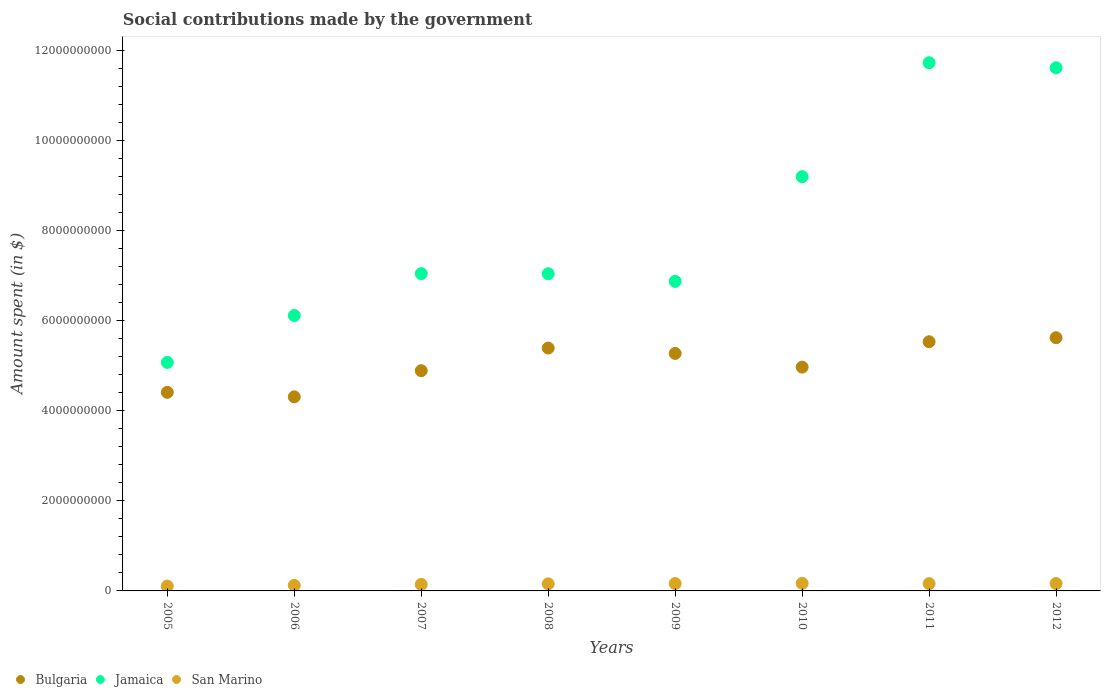Is the number of dotlines equal to the number of legend labels?
Provide a short and direct response. Yes. What is the amount spent on social contributions in Bulgaria in 2012?
Offer a very short reply. 5.62e+09. Across all years, what is the maximum amount spent on social contributions in San Marino?
Your answer should be compact. 1.68e+08. Across all years, what is the minimum amount spent on social contributions in Bulgaria?
Offer a very short reply. 4.31e+09. In which year was the amount spent on social contributions in San Marino maximum?
Keep it short and to the point. 2010. What is the total amount spent on social contributions in Jamaica in the graph?
Provide a short and direct response. 6.47e+1. What is the difference between the amount spent on social contributions in Bulgaria in 2008 and that in 2012?
Keep it short and to the point. -2.30e+08. What is the difference between the amount spent on social contributions in Bulgaria in 2006 and the amount spent on social contributions in San Marino in 2009?
Keep it short and to the point. 4.15e+09. What is the average amount spent on social contributions in Bulgaria per year?
Your response must be concise. 5.05e+09. In the year 2005, what is the difference between the amount spent on social contributions in San Marino and amount spent on social contributions in Jamaica?
Your answer should be very brief. -4.97e+09. In how many years, is the amount spent on social contributions in Bulgaria greater than 8400000000 $?
Give a very brief answer. 0. What is the ratio of the amount spent on social contributions in San Marino in 2008 to that in 2009?
Provide a short and direct response. 0.96. Is the amount spent on social contributions in Jamaica in 2006 less than that in 2009?
Make the answer very short. Yes. Is the difference between the amount spent on social contributions in San Marino in 2008 and 2009 greater than the difference between the amount spent on social contributions in Jamaica in 2008 and 2009?
Keep it short and to the point. No. What is the difference between the highest and the second highest amount spent on social contributions in San Marino?
Provide a short and direct response. 3.69e+06. What is the difference between the highest and the lowest amount spent on social contributions in San Marino?
Provide a succinct answer. 6.01e+07. Does the amount spent on social contributions in Bulgaria monotonically increase over the years?
Make the answer very short. No. Is the amount spent on social contributions in San Marino strictly greater than the amount spent on social contributions in Bulgaria over the years?
Ensure brevity in your answer.  No. How many years are there in the graph?
Offer a very short reply. 8. What is the difference between two consecutive major ticks on the Y-axis?
Provide a succinct answer. 2.00e+09. Does the graph contain any zero values?
Offer a very short reply. No. Where does the legend appear in the graph?
Your response must be concise. Bottom left. How many legend labels are there?
Your answer should be very brief. 3. How are the legend labels stacked?
Your response must be concise. Horizontal. What is the title of the graph?
Your answer should be very brief. Social contributions made by the government. Does "Chile" appear as one of the legend labels in the graph?
Give a very brief answer. No. What is the label or title of the Y-axis?
Your answer should be compact. Amount spent (in $). What is the Amount spent (in $) in Bulgaria in 2005?
Offer a terse response. 4.41e+09. What is the Amount spent (in $) in Jamaica in 2005?
Give a very brief answer. 5.07e+09. What is the Amount spent (in $) of San Marino in 2005?
Make the answer very short. 1.08e+08. What is the Amount spent (in $) in Bulgaria in 2006?
Offer a terse response. 4.31e+09. What is the Amount spent (in $) in Jamaica in 2006?
Provide a succinct answer. 6.12e+09. What is the Amount spent (in $) in San Marino in 2006?
Provide a short and direct response. 1.23e+08. What is the Amount spent (in $) of Bulgaria in 2007?
Give a very brief answer. 4.89e+09. What is the Amount spent (in $) of Jamaica in 2007?
Give a very brief answer. 7.05e+09. What is the Amount spent (in $) in San Marino in 2007?
Provide a succinct answer. 1.44e+08. What is the Amount spent (in $) in Bulgaria in 2008?
Provide a succinct answer. 5.39e+09. What is the Amount spent (in $) in Jamaica in 2008?
Keep it short and to the point. 7.04e+09. What is the Amount spent (in $) of San Marino in 2008?
Provide a succinct answer. 1.58e+08. What is the Amount spent (in $) in Bulgaria in 2009?
Your answer should be compact. 5.27e+09. What is the Amount spent (in $) in Jamaica in 2009?
Provide a succinct answer. 6.87e+09. What is the Amount spent (in $) of San Marino in 2009?
Your response must be concise. 1.64e+08. What is the Amount spent (in $) of Bulgaria in 2010?
Your response must be concise. 4.97e+09. What is the Amount spent (in $) in Jamaica in 2010?
Make the answer very short. 9.20e+09. What is the Amount spent (in $) of San Marino in 2010?
Your answer should be compact. 1.68e+08. What is the Amount spent (in $) of Bulgaria in 2011?
Your answer should be very brief. 5.53e+09. What is the Amount spent (in $) of Jamaica in 2011?
Your answer should be very brief. 1.17e+1. What is the Amount spent (in $) of San Marino in 2011?
Make the answer very short. 1.62e+08. What is the Amount spent (in $) in Bulgaria in 2012?
Offer a terse response. 5.62e+09. What is the Amount spent (in $) of Jamaica in 2012?
Offer a terse response. 1.16e+1. What is the Amount spent (in $) of San Marino in 2012?
Make the answer very short. 1.64e+08. Across all years, what is the maximum Amount spent (in $) in Bulgaria?
Your response must be concise. 5.62e+09. Across all years, what is the maximum Amount spent (in $) of Jamaica?
Offer a very short reply. 1.17e+1. Across all years, what is the maximum Amount spent (in $) of San Marino?
Make the answer very short. 1.68e+08. Across all years, what is the minimum Amount spent (in $) of Bulgaria?
Give a very brief answer. 4.31e+09. Across all years, what is the minimum Amount spent (in $) in Jamaica?
Your response must be concise. 5.07e+09. Across all years, what is the minimum Amount spent (in $) of San Marino?
Offer a very short reply. 1.08e+08. What is the total Amount spent (in $) in Bulgaria in the graph?
Give a very brief answer. 4.04e+1. What is the total Amount spent (in $) of Jamaica in the graph?
Give a very brief answer. 6.47e+1. What is the total Amount spent (in $) of San Marino in the graph?
Give a very brief answer. 1.19e+09. What is the difference between the Amount spent (in $) of Bulgaria in 2005 and that in 2006?
Offer a very short reply. 1.01e+08. What is the difference between the Amount spent (in $) in Jamaica in 2005 and that in 2006?
Offer a very short reply. -1.04e+09. What is the difference between the Amount spent (in $) of San Marino in 2005 and that in 2006?
Your response must be concise. -1.56e+07. What is the difference between the Amount spent (in $) in Bulgaria in 2005 and that in 2007?
Provide a short and direct response. -4.81e+08. What is the difference between the Amount spent (in $) of Jamaica in 2005 and that in 2007?
Your response must be concise. -1.97e+09. What is the difference between the Amount spent (in $) of San Marino in 2005 and that in 2007?
Offer a terse response. -3.61e+07. What is the difference between the Amount spent (in $) of Bulgaria in 2005 and that in 2008?
Your answer should be compact. -9.83e+08. What is the difference between the Amount spent (in $) of Jamaica in 2005 and that in 2008?
Offer a very short reply. -1.97e+09. What is the difference between the Amount spent (in $) in San Marino in 2005 and that in 2008?
Provide a succinct answer. -4.99e+07. What is the difference between the Amount spent (in $) in Bulgaria in 2005 and that in 2009?
Keep it short and to the point. -8.63e+08. What is the difference between the Amount spent (in $) of Jamaica in 2005 and that in 2009?
Your answer should be compact. -1.80e+09. What is the difference between the Amount spent (in $) in San Marino in 2005 and that in 2009?
Your response must be concise. -5.61e+07. What is the difference between the Amount spent (in $) of Bulgaria in 2005 and that in 2010?
Keep it short and to the point. -5.60e+08. What is the difference between the Amount spent (in $) of Jamaica in 2005 and that in 2010?
Provide a short and direct response. -4.13e+09. What is the difference between the Amount spent (in $) in San Marino in 2005 and that in 2010?
Keep it short and to the point. -6.01e+07. What is the difference between the Amount spent (in $) of Bulgaria in 2005 and that in 2011?
Offer a very short reply. -1.12e+09. What is the difference between the Amount spent (in $) of Jamaica in 2005 and that in 2011?
Your answer should be very brief. -6.65e+09. What is the difference between the Amount spent (in $) in San Marino in 2005 and that in 2011?
Keep it short and to the point. -5.40e+07. What is the difference between the Amount spent (in $) in Bulgaria in 2005 and that in 2012?
Offer a very short reply. -1.21e+09. What is the difference between the Amount spent (in $) of Jamaica in 2005 and that in 2012?
Provide a short and direct response. -6.54e+09. What is the difference between the Amount spent (in $) in San Marino in 2005 and that in 2012?
Your answer should be very brief. -5.64e+07. What is the difference between the Amount spent (in $) of Bulgaria in 2006 and that in 2007?
Provide a succinct answer. -5.81e+08. What is the difference between the Amount spent (in $) of Jamaica in 2006 and that in 2007?
Ensure brevity in your answer.  -9.30e+08. What is the difference between the Amount spent (in $) of San Marino in 2006 and that in 2007?
Ensure brevity in your answer.  -2.05e+07. What is the difference between the Amount spent (in $) of Bulgaria in 2006 and that in 2008?
Offer a very short reply. -1.08e+09. What is the difference between the Amount spent (in $) of Jamaica in 2006 and that in 2008?
Provide a short and direct response. -9.27e+08. What is the difference between the Amount spent (in $) of San Marino in 2006 and that in 2008?
Provide a short and direct response. -3.43e+07. What is the difference between the Amount spent (in $) in Bulgaria in 2006 and that in 2009?
Make the answer very short. -9.64e+08. What is the difference between the Amount spent (in $) in Jamaica in 2006 and that in 2009?
Your answer should be very brief. -7.58e+08. What is the difference between the Amount spent (in $) in San Marino in 2006 and that in 2009?
Give a very brief answer. -4.05e+07. What is the difference between the Amount spent (in $) in Bulgaria in 2006 and that in 2010?
Your response must be concise. -6.61e+08. What is the difference between the Amount spent (in $) of Jamaica in 2006 and that in 2010?
Offer a very short reply. -3.08e+09. What is the difference between the Amount spent (in $) of San Marino in 2006 and that in 2010?
Your answer should be very brief. -4.44e+07. What is the difference between the Amount spent (in $) of Bulgaria in 2006 and that in 2011?
Your response must be concise. -1.22e+09. What is the difference between the Amount spent (in $) in Jamaica in 2006 and that in 2011?
Give a very brief answer. -5.61e+09. What is the difference between the Amount spent (in $) of San Marino in 2006 and that in 2011?
Provide a succinct answer. -3.84e+07. What is the difference between the Amount spent (in $) of Bulgaria in 2006 and that in 2012?
Make the answer very short. -1.31e+09. What is the difference between the Amount spent (in $) in Jamaica in 2006 and that in 2012?
Give a very brief answer. -5.50e+09. What is the difference between the Amount spent (in $) of San Marino in 2006 and that in 2012?
Offer a very short reply. -4.08e+07. What is the difference between the Amount spent (in $) of Bulgaria in 2007 and that in 2008?
Offer a very short reply. -5.02e+08. What is the difference between the Amount spent (in $) of Jamaica in 2007 and that in 2008?
Keep it short and to the point. 2.79e+06. What is the difference between the Amount spent (in $) in San Marino in 2007 and that in 2008?
Your answer should be very brief. -1.39e+07. What is the difference between the Amount spent (in $) in Bulgaria in 2007 and that in 2009?
Offer a terse response. -3.83e+08. What is the difference between the Amount spent (in $) in Jamaica in 2007 and that in 2009?
Ensure brevity in your answer.  1.72e+08. What is the difference between the Amount spent (in $) in San Marino in 2007 and that in 2009?
Make the answer very short. -2.00e+07. What is the difference between the Amount spent (in $) in Bulgaria in 2007 and that in 2010?
Your answer should be very brief. -7.95e+07. What is the difference between the Amount spent (in $) in Jamaica in 2007 and that in 2010?
Your answer should be compact. -2.15e+09. What is the difference between the Amount spent (in $) in San Marino in 2007 and that in 2010?
Provide a short and direct response. -2.40e+07. What is the difference between the Amount spent (in $) of Bulgaria in 2007 and that in 2011?
Offer a very short reply. -6.42e+08. What is the difference between the Amount spent (in $) in Jamaica in 2007 and that in 2011?
Provide a succinct answer. -4.68e+09. What is the difference between the Amount spent (in $) in San Marino in 2007 and that in 2011?
Provide a short and direct response. -1.80e+07. What is the difference between the Amount spent (in $) in Bulgaria in 2007 and that in 2012?
Offer a very short reply. -7.32e+08. What is the difference between the Amount spent (in $) of Jamaica in 2007 and that in 2012?
Make the answer very short. -4.57e+09. What is the difference between the Amount spent (in $) of San Marino in 2007 and that in 2012?
Provide a short and direct response. -2.03e+07. What is the difference between the Amount spent (in $) of Bulgaria in 2008 and that in 2009?
Your response must be concise. 1.20e+08. What is the difference between the Amount spent (in $) of Jamaica in 2008 and that in 2009?
Provide a succinct answer. 1.69e+08. What is the difference between the Amount spent (in $) in San Marino in 2008 and that in 2009?
Your answer should be very brief. -6.16e+06. What is the difference between the Amount spent (in $) of Bulgaria in 2008 and that in 2010?
Make the answer very short. 4.23e+08. What is the difference between the Amount spent (in $) of Jamaica in 2008 and that in 2010?
Your response must be concise. -2.16e+09. What is the difference between the Amount spent (in $) of San Marino in 2008 and that in 2010?
Ensure brevity in your answer.  -1.01e+07. What is the difference between the Amount spent (in $) of Bulgaria in 2008 and that in 2011?
Ensure brevity in your answer.  -1.40e+08. What is the difference between the Amount spent (in $) in Jamaica in 2008 and that in 2011?
Your answer should be compact. -4.68e+09. What is the difference between the Amount spent (in $) in San Marino in 2008 and that in 2011?
Your answer should be very brief. -4.11e+06. What is the difference between the Amount spent (in $) in Bulgaria in 2008 and that in 2012?
Provide a short and direct response. -2.30e+08. What is the difference between the Amount spent (in $) of Jamaica in 2008 and that in 2012?
Ensure brevity in your answer.  -4.57e+09. What is the difference between the Amount spent (in $) in San Marino in 2008 and that in 2012?
Provide a succinct answer. -6.42e+06. What is the difference between the Amount spent (in $) of Bulgaria in 2009 and that in 2010?
Provide a short and direct response. 3.03e+08. What is the difference between the Amount spent (in $) of Jamaica in 2009 and that in 2010?
Ensure brevity in your answer.  -2.33e+09. What is the difference between the Amount spent (in $) in San Marino in 2009 and that in 2010?
Your answer should be very brief. -3.95e+06. What is the difference between the Amount spent (in $) in Bulgaria in 2009 and that in 2011?
Ensure brevity in your answer.  -2.60e+08. What is the difference between the Amount spent (in $) in Jamaica in 2009 and that in 2011?
Your answer should be compact. -4.85e+09. What is the difference between the Amount spent (in $) in San Marino in 2009 and that in 2011?
Provide a succinct answer. 2.05e+06. What is the difference between the Amount spent (in $) of Bulgaria in 2009 and that in 2012?
Provide a short and direct response. -3.49e+08. What is the difference between the Amount spent (in $) of Jamaica in 2009 and that in 2012?
Make the answer very short. -4.74e+09. What is the difference between the Amount spent (in $) in San Marino in 2009 and that in 2012?
Provide a short and direct response. -2.64e+05. What is the difference between the Amount spent (in $) in Bulgaria in 2010 and that in 2011?
Make the answer very short. -5.63e+08. What is the difference between the Amount spent (in $) in Jamaica in 2010 and that in 2011?
Make the answer very short. -2.53e+09. What is the difference between the Amount spent (in $) of San Marino in 2010 and that in 2011?
Offer a terse response. 6.01e+06. What is the difference between the Amount spent (in $) in Bulgaria in 2010 and that in 2012?
Your response must be concise. -6.53e+08. What is the difference between the Amount spent (in $) of Jamaica in 2010 and that in 2012?
Keep it short and to the point. -2.42e+09. What is the difference between the Amount spent (in $) in San Marino in 2010 and that in 2012?
Keep it short and to the point. 3.69e+06. What is the difference between the Amount spent (in $) in Bulgaria in 2011 and that in 2012?
Give a very brief answer. -8.99e+07. What is the difference between the Amount spent (in $) of Jamaica in 2011 and that in 2012?
Make the answer very short. 1.11e+08. What is the difference between the Amount spent (in $) of San Marino in 2011 and that in 2012?
Your answer should be compact. -2.32e+06. What is the difference between the Amount spent (in $) of Bulgaria in 2005 and the Amount spent (in $) of Jamaica in 2006?
Give a very brief answer. -1.71e+09. What is the difference between the Amount spent (in $) of Bulgaria in 2005 and the Amount spent (in $) of San Marino in 2006?
Provide a short and direct response. 4.29e+09. What is the difference between the Amount spent (in $) in Jamaica in 2005 and the Amount spent (in $) in San Marino in 2006?
Your response must be concise. 4.95e+09. What is the difference between the Amount spent (in $) of Bulgaria in 2005 and the Amount spent (in $) of Jamaica in 2007?
Provide a short and direct response. -2.64e+09. What is the difference between the Amount spent (in $) of Bulgaria in 2005 and the Amount spent (in $) of San Marino in 2007?
Provide a short and direct response. 4.27e+09. What is the difference between the Amount spent (in $) of Jamaica in 2005 and the Amount spent (in $) of San Marino in 2007?
Ensure brevity in your answer.  4.93e+09. What is the difference between the Amount spent (in $) in Bulgaria in 2005 and the Amount spent (in $) in Jamaica in 2008?
Your answer should be compact. -2.63e+09. What is the difference between the Amount spent (in $) in Bulgaria in 2005 and the Amount spent (in $) in San Marino in 2008?
Give a very brief answer. 4.25e+09. What is the difference between the Amount spent (in $) of Jamaica in 2005 and the Amount spent (in $) of San Marino in 2008?
Provide a succinct answer. 4.92e+09. What is the difference between the Amount spent (in $) of Bulgaria in 2005 and the Amount spent (in $) of Jamaica in 2009?
Offer a very short reply. -2.46e+09. What is the difference between the Amount spent (in $) of Bulgaria in 2005 and the Amount spent (in $) of San Marino in 2009?
Make the answer very short. 4.25e+09. What is the difference between the Amount spent (in $) of Jamaica in 2005 and the Amount spent (in $) of San Marino in 2009?
Your answer should be very brief. 4.91e+09. What is the difference between the Amount spent (in $) of Bulgaria in 2005 and the Amount spent (in $) of Jamaica in 2010?
Provide a short and direct response. -4.79e+09. What is the difference between the Amount spent (in $) of Bulgaria in 2005 and the Amount spent (in $) of San Marino in 2010?
Your answer should be very brief. 4.24e+09. What is the difference between the Amount spent (in $) of Jamaica in 2005 and the Amount spent (in $) of San Marino in 2010?
Provide a short and direct response. 4.91e+09. What is the difference between the Amount spent (in $) of Bulgaria in 2005 and the Amount spent (in $) of Jamaica in 2011?
Your answer should be compact. -7.32e+09. What is the difference between the Amount spent (in $) of Bulgaria in 2005 and the Amount spent (in $) of San Marino in 2011?
Keep it short and to the point. 4.25e+09. What is the difference between the Amount spent (in $) of Jamaica in 2005 and the Amount spent (in $) of San Marino in 2011?
Your response must be concise. 4.91e+09. What is the difference between the Amount spent (in $) of Bulgaria in 2005 and the Amount spent (in $) of Jamaica in 2012?
Your answer should be compact. -7.21e+09. What is the difference between the Amount spent (in $) of Bulgaria in 2005 and the Amount spent (in $) of San Marino in 2012?
Your answer should be very brief. 4.25e+09. What is the difference between the Amount spent (in $) of Jamaica in 2005 and the Amount spent (in $) of San Marino in 2012?
Provide a succinct answer. 4.91e+09. What is the difference between the Amount spent (in $) of Bulgaria in 2006 and the Amount spent (in $) of Jamaica in 2007?
Give a very brief answer. -2.74e+09. What is the difference between the Amount spent (in $) in Bulgaria in 2006 and the Amount spent (in $) in San Marino in 2007?
Keep it short and to the point. 4.17e+09. What is the difference between the Amount spent (in $) in Jamaica in 2006 and the Amount spent (in $) in San Marino in 2007?
Provide a succinct answer. 5.97e+09. What is the difference between the Amount spent (in $) in Bulgaria in 2006 and the Amount spent (in $) in Jamaica in 2008?
Your answer should be very brief. -2.73e+09. What is the difference between the Amount spent (in $) of Bulgaria in 2006 and the Amount spent (in $) of San Marino in 2008?
Keep it short and to the point. 4.15e+09. What is the difference between the Amount spent (in $) of Jamaica in 2006 and the Amount spent (in $) of San Marino in 2008?
Your answer should be compact. 5.96e+09. What is the difference between the Amount spent (in $) of Bulgaria in 2006 and the Amount spent (in $) of Jamaica in 2009?
Provide a short and direct response. -2.56e+09. What is the difference between the Amount spent (in $) of Bulgaria in 2006 and the Amount spent (in $) of San Marino in 2009?
Keep it short and to the point. 4.15e+09. What is the difference between the Amount spent (in $) in Jamaica in 2006 and the Amount spent (in $) in San Marino in 2009?
Your response must be concise. 5.95e+09. What is the difference between the Amount spent (in $) in Bulgaria in 2006 and the Amount spent (in $) in Jamaica in 2010?
Make the answer very short. -4.89e+09. What is the difference between the Amount spent (in $) in Bulgaria in 2006 and the Amount spent (in $) in San Marino in 2010?
Provide a succinct answer. 4.14e+09. What is the difference between the Amount spent (in $) of Jamaica in 2006 and the Amount spent (in $) of San Marino in 2010?
Offer a terse response. 5.95e+09. What is the difference between the Amount spent (in $) of Bulgaria in 2006 and the Amount spent (in $) of Jamaica in 2011?
Ensure brevity in your answer.  -7.42e+09. What is the difference between the Amount spent (in $) of Bulgaria in 2006 and the Amount spent (in $) of San Marino in 2011?
Give a very brief answer. 4.15e+09. What is the difference between the Amount spent (in $) in Jamaica in 2006 and the Amount spent (in $) in San Marino in 2011?
Offer a terse response. 5.95e+09. What is the difference between the Amount spent (in $) in Bulgaria in 2006 and the Amount spent (in $) in Jamaica in 2012?
Provide a succinct answer. -7.31e+09. What is the difference between the Amount spent (in $) of Bulgaria in 2006 and the Amount spent (in $) of San Marino in 2012?
Your answer should be very brief. 4.15e+09. What is the difference between the Amount spent (in $) in Jamaica in 2006 and the Amount spent (in $) in San Marino in 2012?
Offer a very short reply. 5.95e+09. What is the difference between the Amount spent (in $) of Bulgaria in 2007 and the Amount spent (in $) of Jamaica in 2008?
Keep it short and to the point. -2.15e+09. What is the difference between the Amount spent (in $) of Bulgaria in 2007 and the Amount spent (in $) of San Marino in 2008?
Provide a short and direct response. 4.73e+09. What is the difference between the Amount spent (in $) of Jamaica in 2007 and the Amount spent (in $) of San Marino in 2008?
Provide a succinct answer. 6.89e+09. What is the difference between the Amount spent (in $) in Bulgaria in 2007 and the Amount spent (in $) in Jamaica in 2009?
Your response must be concise. -1.98e+09. What is the difference between the Amount spent (in $) in Bulgaria in 2007 and the Amount spent (in $) in San Marino in 2009?
Your response must be concise. 4.73e+09. What is the difference between the Amount spent (in $) of Jamaica in 2007 and the Amount spent (in $) of San Marino in 2009?
Offer a very short reply. 6.88e+09. What is the difference between the Amount spent (in $) in Bulgaria in 2007 and the Amount spent (in $) in Jamaica in 2010?
Your answer should be very brief. -4.31e+09. What is the difference between the Amount spent (in $) of Bulgaria in 2007 and the Amount spent (in $) of San Marino in 2010?
Your response must be concise. 4.72e+09. What is the difference between the Amount spent (in $) in Jamaica in 2007 and the Amount spent (in $) in San Marino in 2010?
Give a very brief answer. 6.88e+09. What is the difference between the Amount spent (in $) of Bulgaria in 2007 and the Amount spent (in $) of Jamaica in 2011?
Provide a short and direct response. -6.84e+09. What is the difference between the Amount spent (in $) in Bulgaria in 2007 and the Amount spent (in $) in San Marino in 2011?
Your response must be concise. 4.73e+09. What is the difference between the Amount spent (in $) of Jamaica in 2007 and the Amount spent (in $) of San Marino in 2011?
Offer a terse response. 6.88e+09. What is the difference between the Amount spent (in $) of Bulgaria in 2007 and the Amount spent (in $) of Jamaica in 2012?
Keep it short and to the point. -6.73e+09. What is the difference between the Amount spent (in $) of Bulgaria in 2007 and the Amount spent (in $) of San Marino in 2012?
Keep it short and to the point. 4.73e+09. What is the difference between the Amount spent (in $) in Jamaica in 2007 and the Amount spent (in $) in San Marino in 2012?
Give a very brief answer. 6.88e+09. What is the difference between the Amount spent (in $) of Bulgaria in 2008 and the Amount spent (in $) of Jamaica in 2009?
Your answer should be compact. -1.48e+09. What is the difference between the Amount spent (in $) in Bulgaria in 2008 and the Amount spent (in $) in San Marino in 2009?
Provide a short and direct response. 5.23e+09. What is the difference between the Amount spent (in $) of Jamaica in 2008 and the Amount spent (in $) of San Marino in 2009?
Your response must be concise. 6.88e+09. What is the difference between the Amount spent (in $) of Bulgaria in 2008 and the Amount spent (in $) of Jamaica in 2010?
Offer a very short reply. -3.81e+09. What is the difference between the Amount spent (in $) of Bulgaria in 2008 and the Amount spent (in $) of San Marino in 2010?
Make the answer very short. 5.22e+09. What is the difference between the Amount spent (in $) of Jamaica in 2008 and the Amount spent (in $) of San Marino in 2010?
Keep it short and to the point. 6.88e+09. What is the difference between the Amount spent (in $) of Bulgaria in 2008 and the Amount spent (in $) of Jamaica in 2011?
Offer a very short reply. -6.34e+09. What is the difference between the Amount spent (in $) in Bulgaria in 2008 and the Amount spent (in $) in San Marino in 2011?
Keep it short and to the point. 5.23e+09. What is the difference between the Amount spent (in $) of Jamaica in 2008 and the Amount spent (in $) of San Marino in 2011?
Provide a short and direct response. 6.88e+09. What is the difference between the Amount spent (in $) in Bulgaria in 2008 and the Amount spent (in $) in Jamaica in 2012?
Provide a short and direct response. -6.22e+09. What is the difference between the Amount spent (in $) of Bulgaria in 2008 and the Amount spent (in $) of San Marino in 2012?
Provide a succinct answer. 5.23e+09. What is the difference between the Amount spent (in $) in Jamaica in 2008 and the Amount spent (in $) in San Marino in 2012?
Make the answer very short. 6.88e+09. What is the difference between the Amount spent (in $) in Bulgaria in 2009 and the Amount spent (in $) in Jamaica in 2010?
Offer a very short reply. -3.93e+09. What is the difference between the Amount spent (in $) in Bulgaria in 2009 and the Amount spent (in $) in San Marino in 2010?
Provide a short and direct response. 5.11e+09. What is the difference between the Amount spent (in $) of Jamaica in 2009 and the Amount spent (in $) of San Marino in 2010?
Your answer should be compact. 6.71e+09. What is the difference between the Amount spent (in $) in Bulgaria in 2009 and the Amount spent (in $) in Jamaica in 2011?
Your answer should be compact. -6.45e+09. What is the difference between the Amount spent (in $) of Bulgaria in 2009 and the Amount spent (in $) of San Marino in 2011?
Your answer should be compact. 5.11e+09. What is the difference between the Amount spent (in $) of Jamaica in 2009 and the Amount spent (in $) of San Marino in 2011?
Offer a very short reply. 6.71e+09. What is the difference between the Amount spent (in $) of Bulgaria in 2009 and the Amount spent (in $) of Jamaica in 2012?
Give a very brief answer. -6.34e+09. What is the difference between the Amount spent (in $) of Bulgaria in 2009 and the Amount spent (in $) of San Marino in 2012?
Your answer should be very brief. 5.11e+09. What is the difference between the Amount spent (in $) in Jamaica in 2009 and the Amount spent (in $) in San Marino in 2012?
Make the answer very short. 6.71e+09. What is the difference between the Amount spent (in $) of Bulgaria in 2010 and the Amount spent (in $) of Jamaica in 2011?
Give a very brief answer. -6.76e+09. What is the difference between the Amount spent (in $) in Bulgaria in 2010 and the Amount spent (in $) in San Marino in 2011?
Offer a terse response. 4.81e+09. What is the difference between the Amount spent (in $) in Jamaica in 2010 and the Amount spent (in $) in San Marino in 2011?
Your answer should be compact. 9.04e+09. What is the difference between the Amount spent (in $) of Bulgaria in 2010 and the Amount spent (in $) of Jamaica in 2012?
Ensure brevity in your answer.  -6.65e+09. What is the difference between the Amount spent (in $) in Bulgaria in 2010 and the Amount spent (in $) in San Marino in 2012?
Offer a terse response. 4.81e+09. What is the difference between the Amount spent (in $) of Jamaica in 2010 and the Amount spent (in $) of San Marino in 2012?
Keep it short and to the point. 9.04e+09. What is the difference between the Amount spent (in $) in Bulgaria in 2011 and the Amount spent (in $) in Jamaica in 2012?
Your answer should be very brief. -6.08e+09. What is the difference between the Amount spent (in $) of Bulgaria in 2011 and the Amount spent (in $) of San Marino in 2012?
Your response must be concise. 5.37e+09. What is the difference between the Amount spent (in $) in Jamaica in 2011 and the Amount spent (in $) in San Marino in 2012?
Offer a terse response. 1.16e+1. What is the average Amount spent (in $) in Bulgaria per year?
Keep it short and to the point. 5.05e+09. What is the average Amount spent (in $) in Jamaica per year?
Offer a terse response. 8.09e+09. What is the average Amount spent (in $) of San Marino per year?
Ensure brevity in your answer.  1.49e+08. In the year 2005, what is the difference between the Amount spent (in $) of Bulgaria and Amount spent (in $) of Jamaica?
Your answer should be very brief. -6.64e+08. In the year 2005, what is the difference between the Amount spent (in $) of Bulgaria and Amount spent (in $) of San Marino?
Ensure brevity in your answer.  4.30e+09. In the year 2005, what is the difference between the Amount spent (in $) of Jamaica and Amount spent (in $) of San Marino?
Your answer should be compact. 4.97e+09. In the year 2006, what is the difference between the Amount spent (in $) in Bulgaria and Amount spent (in $) in Jamaica?
Provide a short and direct response. -1.81e+09. In the year 2006, what is the difference between the Amount spent (in $) in Bulgaria and Amount spent (in $) in San Marino?
Make the answer very short. 4.19e+09. In the year 2006, what is the difference between the Amount spent (in $) in Jamaica and Amount spent (in $) in San Marino?
Provide a short and direct response. 5.99e+09. In the year 2007, what is the difference between the Amount spent (in $) of Bulgaria and Amount spent (in $) of Jamaica?
Provide a succinct answer. -2.16e+09. In the year 2007, what is the difference between the Amount spent (in $) in Bulgaria and Amount spent (in $) in San Marino?
Offer a terse response. 4.75e+09. In the year 2007, what is the difference between the Amount spent (in $) of Jamaica and Amount spent (in $) of San Marino?
Keep it short and to the point. 6.90e+09. In the year 2008, what is the difference between the Amount spent (in $) in Bulgaria and Amount spent (in $) in Jamaica?
Provide a succinct answer. -1.65e+09. In the year 2008, what is the difference between the Amount spent (in $) in Bulgaria and Amount spent (in $) in San Marino?
Provide a succinct answer. 5.24e+09. In the year 2008, what is the difference between the Amount spent (in $) of Jamaica and Amount spent (in $) of San Marino?
Provide a succinct answer. 6.89e+09. In the year 2009, what is the difference between the Amount spent (in $) of Bulgaria and Amount spent (in $) of Jamaica?
Make the answer very short. -1.60e+09. In the year 2009, what is the difference between the Amount spent (in $) of Bulgaria and Amount spent (in $) of San Marino?
Your answer should be very brief. 5.11e+09. In the year 2009, what is the difference between the Amount spent (in $) of Jamaica and Amount spent (in $) of San Marino?
Your answer should be compact. 6.71e+09. In the year 2010, what is the difference between the Amount spent (in $) of Bulgaria and Amount spent (in $) of Jamaica?
Ensure brevity in your answer.  -4.23e+09. In the year 2010, what is the difference between the Amount spent (in $) of Bulgaria and Amount spent (in $) of San Marino?
Provide a succinct answer. 4.80e+09. In the year 2010, what is the difference between the Amount spent (in $) of Jamaica and Amount spent (in $) of San Marino?
Your answer should be very brief. 9.03e+09. In the year 2011, what is the difference between the Amount spent (in $) in Bulgaria and Amount spent (in $) in Jamaica?
Provide a succinct answer. -6.20e+09. In the year 2011, what is the difference between the Amount spent (in $) in Bulgaria and Amount spent (in $) in San Marino?
Give a very brief answer. 5.37e+09. In the year 2011, what is the difference between the Amount spent (in $) in Jamaica and Amount spent (in $) in San Marino?
Give a very brief answer. 1.16e+1. In the year 2012, what is the difference between the Amount spent (in $) of Bulgaria and Amount spent (in $) of Jamaica?
Make the answer very short. -5.99e+09. In the year 2012, what is the difference between the Amount spent (in $) in Bulgaria and Amount spent (in $) in San Marino?
Offer a very short reply. 5.46e+09. In the year 2012, what is the difference between the Amount spent (in $) in Jamaica and Amount spent (in $) in San Marino?
Ensure brevity in your answer.  1.15e+1. What is the ratio of the Amount spent (in $) of Bulgaria in 2005 to that in 2006?
Make the answer very short. 1.02. What is the ratio of the Amount spent (in $) of Jamaica in 2005 to that in 2006?
Your answer should be compact. 0.83. What is the ratio of the Amount spent (in $) in San Marino in 2005 to that in 2006?
Provide a succinct answer. 0.87. What is the ratio of the Amount spent (in $) of Bulgaria in 2005 to that in 2007?
Your answer should be very brief. 0.9. What is the ratio of the Amount spent (in $) of Jamaica in 2005 to that in 2007?
Your answer should be very brief. 0.72. What is the ratio of the Amount spent (in $) of San Marino in 2005 to that in 2007?
Your response must be concise. 0.75. What is the ratio of the Amount spent (in $) in Bulgaria in 2005 to that in 2008?
Make the answer very short. 0.82. What is the ratio of the Amount spent (in $) of Jamaica in 2005 to that in 2008?
Your response must be concise. 0.72. What is the ratio of the Amount spent (in $) of San Marino in 2005 to that in 2008?
Provide a succinct answer. 0.68. What is the ratio of the Amount spent (in $) in Bulgaria in 2005 to that in 2009?
Your response must be concise. 0.84. What is the ratio of the Amount spent (in $) in Jamaica in 2005 to that in 2009?
Your response must be concise. 0.74. What is the ratio of the Amount spent (in $) of San Marino in 2005 to that in 2009?
Your answer should be very brief. 0.66. What is the ratio of the Amount spent (in $) in Bulgaria in 2005 to that in 2010?
Your answer should be very brief. 0.89. What is the ratio of the Amount spent (in $) of Jamaica in 2005 to that in 2010?
Offer a terse response. 0.55. What is the ratio of the Amount spent (in $) of San Marino in 2005 to that in 2010?
Provide a succinct answer. 0.64. What is the ratio of the Amount spent (in $) of Bulgaria in 2005 to that in 2011?
Your answer should be very brief. 0.8. What is the ratio of the Amount spent (in $) of Jamaica in 2005 to that in 2011?
Your answer should be compact. 0.43. What is the ratio of the Amount spent (in $) in San Marino in 2005 to that in 2011?
Give a very brief answer. 0.67. What is the ratio of the Amount spent (in $) in Bulgaria in 2005 to that in 2012?
Your response must be concise. 0.78. What is the ratio of the Amount spent (in $) of Jamaica in 2005 to that in 2012?
Give a very brief answer. 0.44. What is the ratio of the Amount spent (in $) of San Marino in 2005 to that in 2012?
Provide a succinct answer. 0.66. What is the ratio of the Amount spent (in $) of Bulgaria in 2006 to that in 2007?
Keep it short and to the point. 0.88. What is the ratio of the Amount spent (in $) of Jamaica in 2006 to that in 2007?
Make the answer very short. 0.87. What is the ratio of the Amount spent (in $) in San Marino in 2006 to that in 2007?
Your answer should be compact. 0.86. What is the ratio of the Amount spent (in $) of Bulgaria in 2006 to that in 2008?
Your answer should be compact. 0.8. What is the ratio of the Amount spent (in $) of Jamaica in 2006 to that in 2008?
Give a very brief answer. 0.87. What is the ratio of the Amount spent (in $) of San Marino in 2006 to that in 2008?
Offer a terse response. 0.78. What is the ratio of the Amount spent (in $) of Bulgaria in 2006 to that in 2009?
Ensure brevity in your answer.  0.82. What is the ratio of the Amount spent (in $) in Jamaica in 2006 to that in 2009?
Provide a succinct answer. 0.89. What is the ratio of the Amount spent (in $) of San Marino in 2006 to that in 2009?
Your answer should be compact. 0.75. What is the ratio of the Amount spent (in $) in Bulgaria in 2006 to that in 2010?
Your response must be concise. 0.87. What is the ratio of the Amount spent (in $) of Jamaica in 2006 to that in 2010?
Keep it short and to the point. 0.66. What is the ratio of the Amount spent (in $) in San Marino in 2006 to that in 2010?
Provide a succinct answer. 0.73. What is the ratio of the Amount spent (in $) of Bulgaria in 2006 to that in 2011?
Your answer should be very brief. 0.78. What is the ratio of the Amount spent (in $) of Jamaica in 2006 to that in 2011?
Give a very brief answer. 0.52. What is the ratio of the Amount spent (in $) in San Marino in 2006 to that in 2011?
Your response must be concise. 0.76. What is the ratio of the Amount spent (in $) in Bulgaria in 2006 to that in 2012?
Provide a succinct answer. 0.77. What is the ratio of the Amount spent (in $) in Jamaica in 2006 to that in 2012?
Make the answer very short. 0.53. What is the ratio of the Amount spent (in $) in San Marino in 2006 to that in 2012?
Provide a succinct answer. 0.75. What is the ratio of the Amount spent (in $) of Bulgaria in 2007 to that in 2008?
Offer a terse response. 0.91. What is the ratio of the Amount spent (in $) in Jamaica in 2007 to that in 2008?
Your answer should be compact. 1. What is the ratio of the Amount spent (in $) in San Marino in 2007 to that in 2008?
Give a very brief answer. 0.91. What is the ratio of the Amount spent (in $) of Bulgaria in 2007 to that in 2009?
Offer a very short reply. 0.93. What is the ratio of the Amount spent (in $) in Jamaica in 2007 to that in 2009?
Ensure brevity in your answer.  1.02. What is the ratio of the Amount spent (in $) of San Marino in 2007 to that in 2009?
Keep it short and to the point. 0.88. What is the ratio of the Amount spent (in $) of Bulgaria in 2007 to that in 2010?
Ensure brevity in your answer.  0.98. What is the ratio of the Amount spent (in $) of Jamaica in 2007 to that in 2010?
Make the answer very short. 0.77. What is the ratio of the Amount spent (in $) in San Marino in 2007 to that in 2010?
Offer a terse response. 0.86. What is the ratio of the Amount spent (in $) of Bulgaria in 2007 to that in 2011?
Offer a very short reply. 0.88. What is the ratio of the Amount spent (in $) in Jamaica in 2007 to that in 2011?
Your answer should be very brief. 0.6. What is the ratio of the Amount spent (in $) of Bulgaria in 2007 to that in 2012?
Give a very brief answer. 0.87. What is the ratio of the Amount spent (in $) in Jamaica in 2007 to that in 2012?
Provide a short and direct response. 0.61. What is the ratio of the Amount spent (in $) of San Marino in 2007 to that in 2012?
Keep it short and to the point. 0.88. What is the ratio of the Amount spent (in $) of Bulgaria in 2008 to that in 2009?
Keep it short and to the point. 1.02. What is the ratio of the Amount spent (in $) of Jamaica in 2008 to that in 2009?
Give a very brief answer. 1.02. What is the ratio of the Amount spent (in $) of San Marino in 2008 to that in 2009?
Your answer should be very brief. 0.96. What is the ratio of the Amount spent (in $) in Bulgaria in 2008 to that in 2010?
Provide a succinct answer. 1.09. What is the ratio of the Amount spent (in $) of Jamaica in 2008 to that in 2010?
Make the answer very short. 0.77. What is the ratio of the Amount spent (in $) of San Marino in 2008 to that in 2010?
Offer a very short reply. 0.94. What is the ratio of the Amount spent (in $) of Bulgaria in 2008 to that in 2011?
Provide a succinct answer. 0.97. What is the ratio of the Amount spent (in $) in Jamaica in 2008 to that in 2011?
Keep it short and to the point. 0.6. What is the ratio of the Amount spent (in $) in San Marino in 2008 to that in 2011?
Offer a very short reply. 0.97. What is the ratio of the Amount spent (in $) in Bulgaria in 2008 to that in 2012?
Provide a short and direct response. 0.96. What is the ratio of the Amount spent (in $) in Jamaica in 2008 to that in 2012?
Your answer should be compact. 0.61. What is the ratio of the Amount spent (in $) of San Marino in 2008 to that in 2012?
Your answer should be compact. 0.96. What is the ratio of the Amount spent (in $) in Bulgaria in 2009 to that in 2010?
Make the answer very short. 1.06. What is the ratio of the Amount spent (in $) of Jamaica in 2009 to that in 2010?
Your answer should be compact. 0.75. What is the ratio of the Amount spent (in $) in San Marino in 2009 to that in 2010?
Ensure brevity in your answer.  0.98. What is the ratio of the Amount spent (in $) in Bulgaria in 2009 to that in 2011?
Ensure brevity in your answer.  0.95. What is the ratio of the Amount spent (in $) in Jamaica in 2009 to that in 2011?
Offer a very short reply. 0.59. What is the ratio of the Amount spent (in $) in San Marino in 2009 to that in 2011?
Offer a terse response. 1.01. What is the ratio of the Amount spent (in $) of Bulgaria in 2009 to that in 2012?
Offer a very short reply. 0.94. What is the ratio of the Amount spent (in $) of Jamaica in 2009 to that in 2012?
Make the answer very short. 0.59. What is the ratio of the Amount spent (in $) in San Marino in 2009 to that in 2012?
Offer a terse response. 1. What is the ratio of the Amount spent (in $) of Bulgaria in 2010 to that in 2011?
Give a very brief answer. 0.9. What is the ratio of the Amount spent (in $) in Jamaica in 2010 to that in 2011?
Provide a succinct answer. 0.78. What is the ratio of the Amount spent (in $) in San Marino in 2010 to that in 2011?
Give a very brief answer. 1.04. What is the ratio of the Amount spent (in $) of Bulgaria in 2010 to that in 2012?
Keep it short and to the point. 0.88. What is the ratio of the Amount spent (in $) in Jamaica in 2010 to that in 2012?
Make the answer very short. 0.79. What is the ratio of the Amount spent (in $) in San Marino in 2010 to that in 2012?
Your response must be concise. 1.02. What is the ratio of the Amount spent (in $) in Bulgaria in 2011 to that in 2012?
Your response must be concise. 0.98. What is the ratio of the Amount spent (in $) of Jamaica in 2011 to that in 2012?
Provide a succinct answer. 1.01. What is the ratio of the Amount spent (in $) in San Marino in 2011 to that in 2012?
Offer a very short reply. 0.99. What is the difference between the highest and the second highest Amount spent (in $) of Bulgaria?
Provide a short and direct response. 8.99e+07. What is the difference between the highest and the second highest Amount spent (in $) of Jamaica?
Your answer should be compact. 1.11e+08. What is the difference between the highest and the second highest Amount spent (in $) in San Marino?
Provide a short and direct response. 3.69e+06. What is the difference between the highest and the lowest Amount spent (in $) of Bulgaria?
Provide a short and direct response. 1.31e+09. What is the difference between the highest and the lowest Amount spent (in $) in Jamaica?
Keep it short and to the point. 6.65e+09. What is the difference between the highest and the lowest Amount spent (in $) in San Marino?
Your answer should be compact. 6.01e+07. 